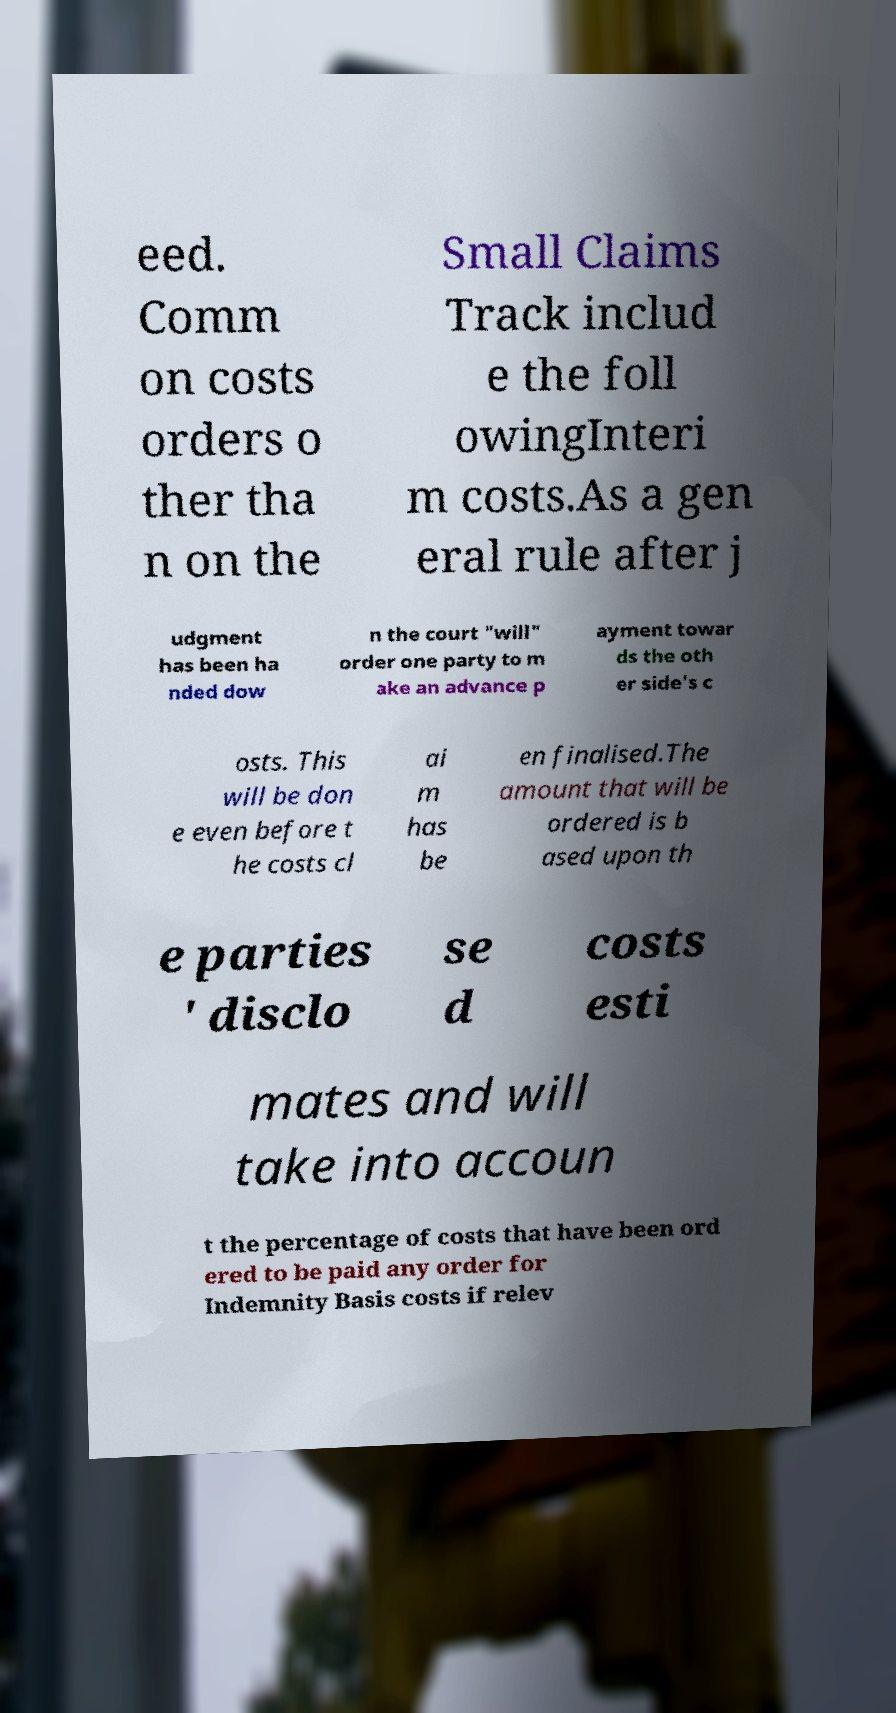Can you accurately transcribe the text from the provided image for me? eed. Comm on costs orders o ther tha n on the Small Claims Track includ e the foll owingInteri m costs.As a gen eral rule after j udgment has been ha nded dow n the court "will" order one party to m ake an advance p ayment towar ds the oth er side's c osts. This will be don e even before t he costs cl ai m has be en finalised.The amount that will be ordered is b ased upon th e parties ' disclo se d costs esti mates and will take into accoun t the percentage of costs that have been ord ered to be paid any order for Indemnity Basis costs if relev 